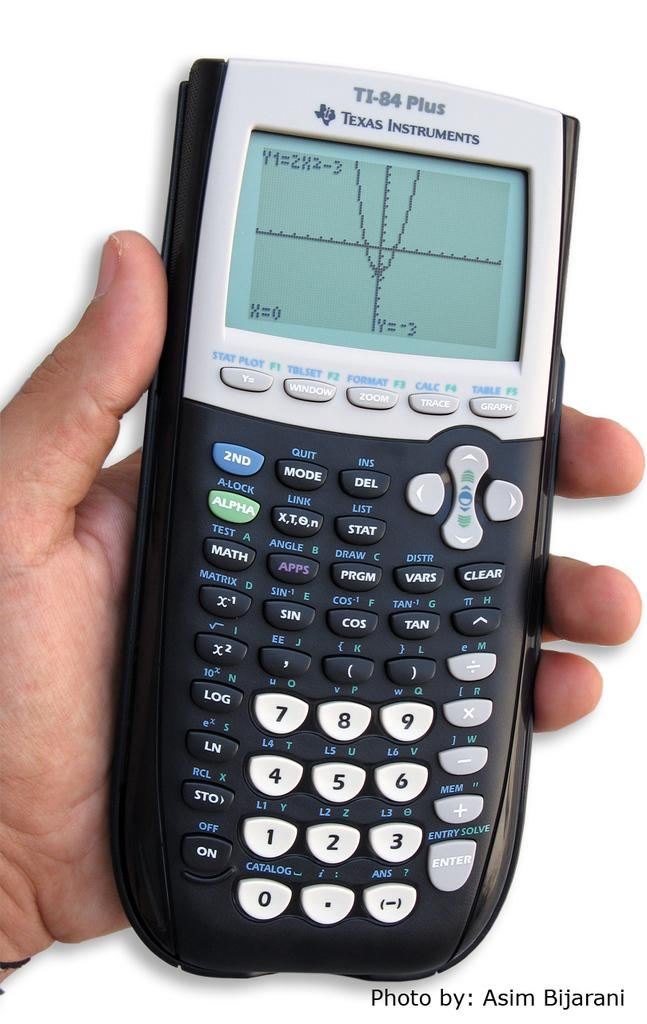<image>
Offer a succinct explanation of the picture presented. A TI-84 plus calculator that was taken by Asim 